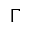<formula> <loc_0><loc_0><loc_500><loc_500>\Gamma</formula> 